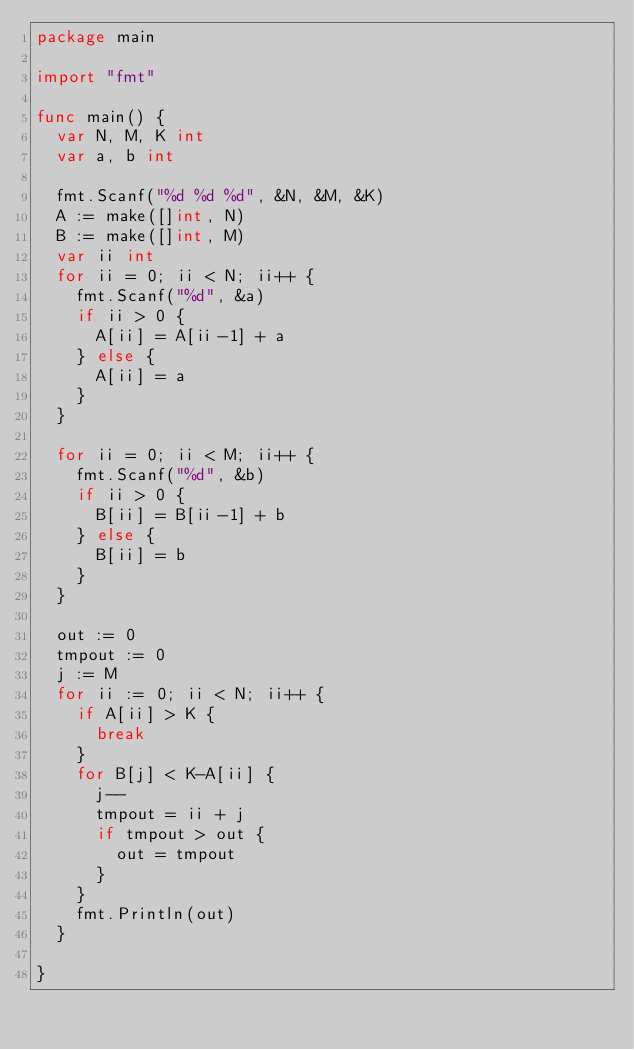Convert code to text. <code><loc_0><loc_0><loc_500><loc_500><_Go_>package main

import "fmt"

func main() {
	var N, M, K int
	var a, b int

	fmt.Scanf("%d %d %d", &N, &M, &K)
	A := make([]int, N)
	B := make([]int, M)
	var ii int
	for ii = 0; ii < N; ii++ {
		fmt.Scanf("%d", &a)
		if ii > 0 {
			A[ii] = A[ii-1] + a
		} else {
			A[ii] = a
		}
	}

	for ii = 0; ii < M; ii++ {
		fmt.Scanf("%d", &b)
		if ii > 0 {
			B[ii] = B[ii-1] + b
		} else {
			B[ii] = b
		}
	}

	out := 0
	tmpout := 0
	j := M
	for ii := 0; ii < N; ii++ {
		if A[ii] > K {
			break
		}
		for B[j] < K-A[ii] {
			j--
			tmpout = ii + j
			if tmpout > out {
				out = tmpout
			}
		}
		fmt.Println(out)
	}

}
</code> 